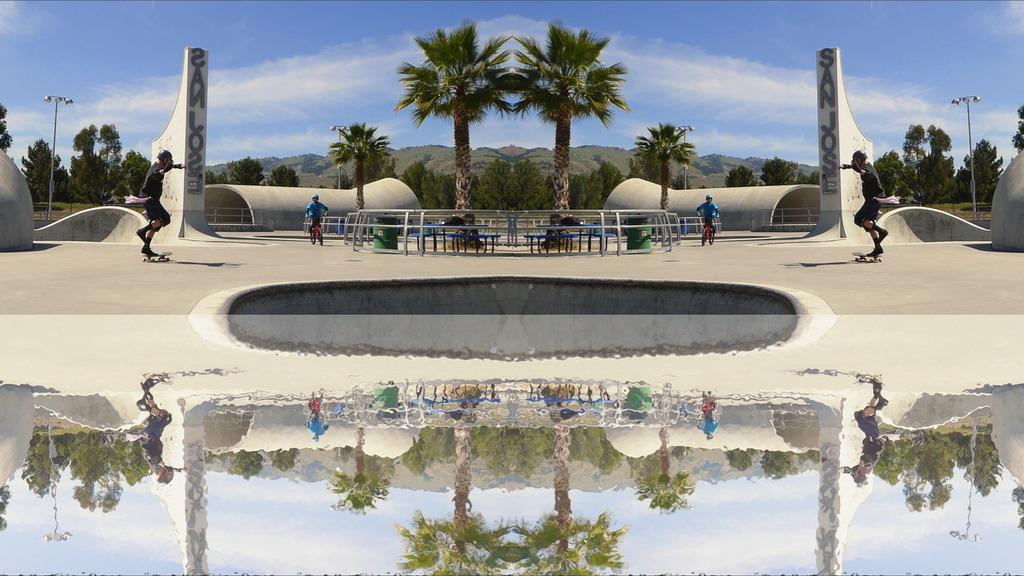How would you summarize this image in a sentence or two? In this image I can see few trees, water, mountains, fencing, green color object, rink board, one person is on the skate board and one person is on the bicycle. The sky is in white and blue color. I can see the mirror image. 